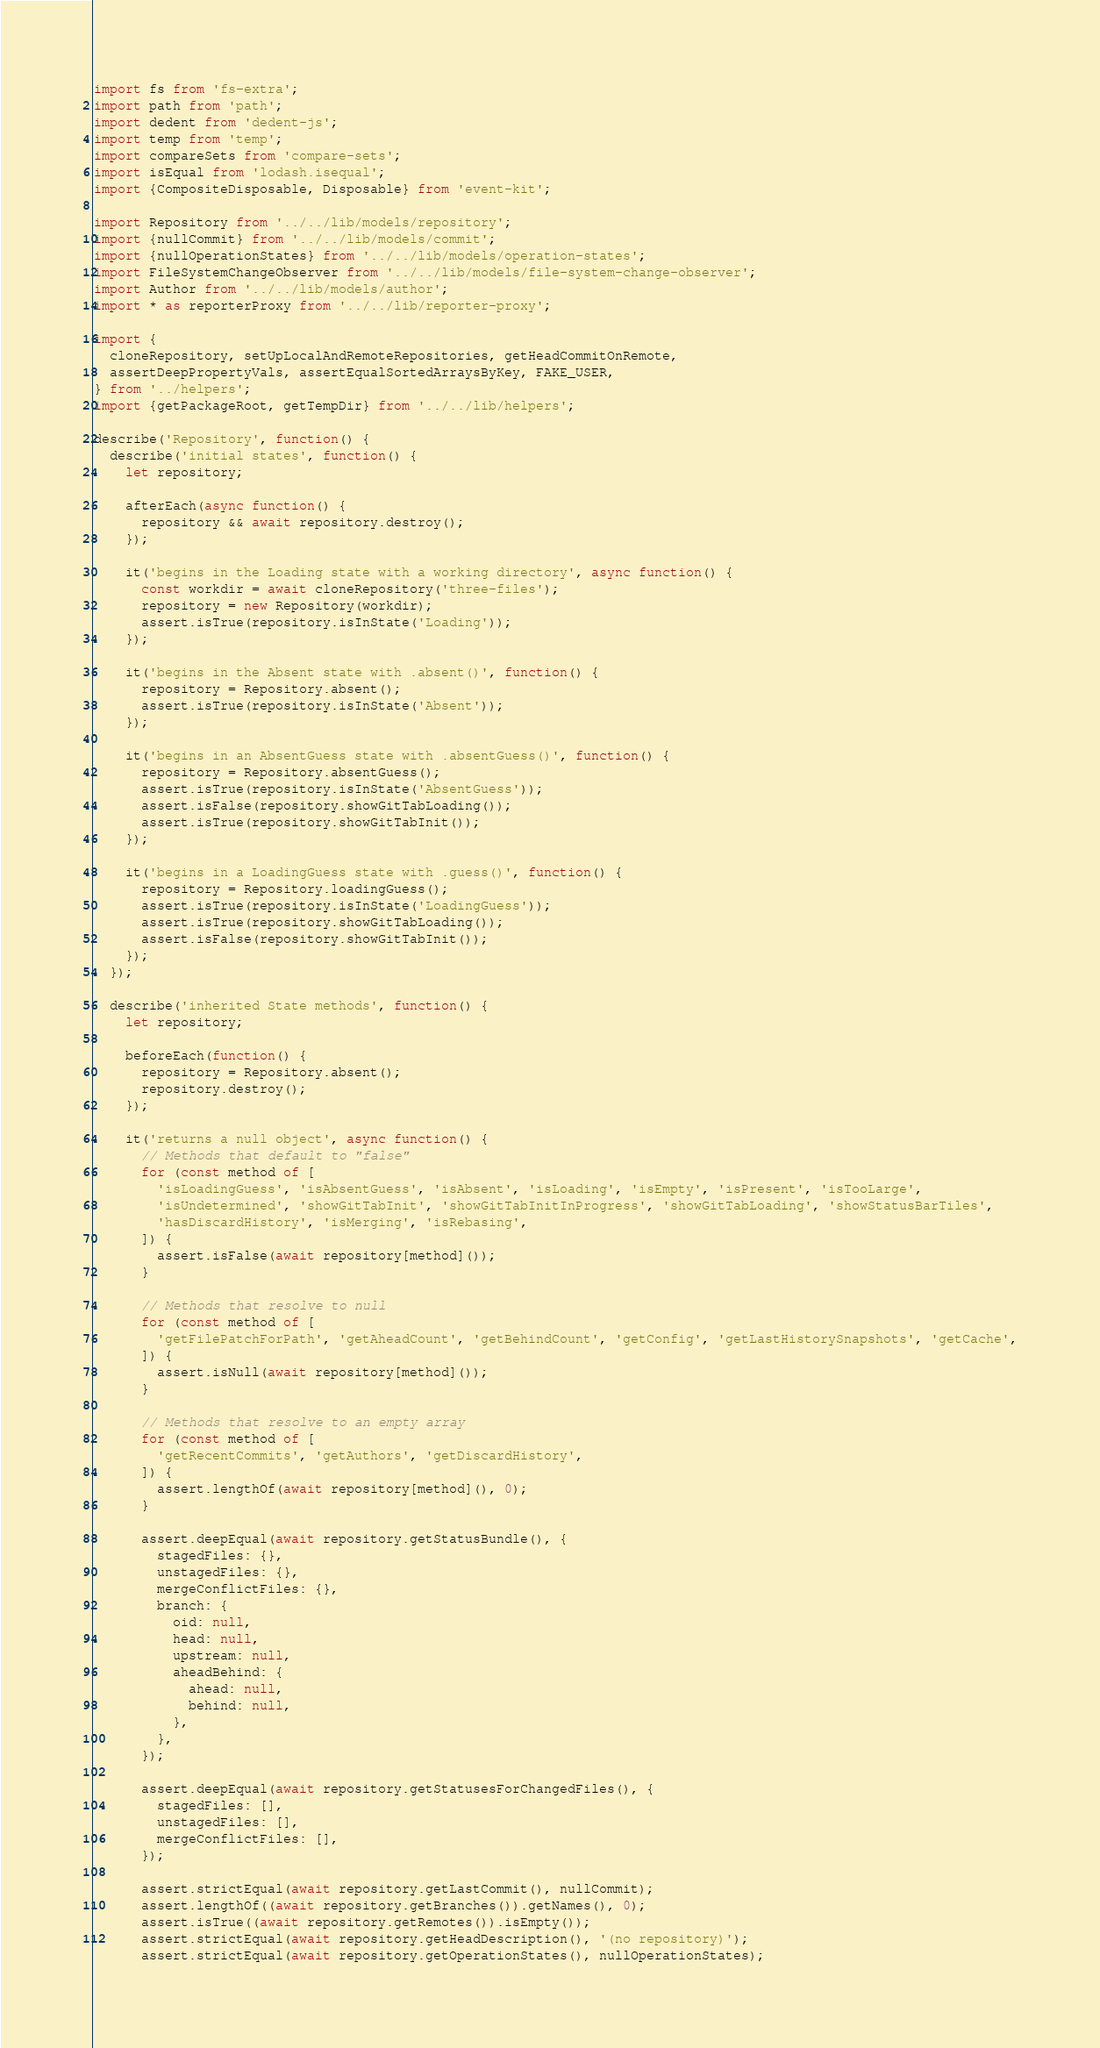<code> <loc_0><loc_0><loc_500><loc_500><_JavaScript_>import fs from 'fs-extra';
import path from 'path';
import dedent from 'dedent-js';
import temp from 'temp';
import compareSets from 'compare-sets';
import isEqual from 'lodash.isequal';
import {CompositeDisposable, Disposable} from 'event-kit';

import Repository from '../../lib/models/repository';
import {nullCommit} from '../../lib/models/commit';
import {nullOperationStates} from '../../lib/models/operation-states';
import FileSystemChangeObserver from '../../lib/models/file-system-change-observer';
import Author from '../../lib/models/author';
import * as reporterProxy from '../../lib/reporter-proxy';

import {
  cloneRepository, setUpLocalAndRemoteRepositories, getHeadCommitOnRemote,
  assertDeepPropertyVals, assertEqualSortedArraysByKey, FAKE_USER,
} from '../helpers';
import {getPackageRoot, getTempDir} from '../../lib/helpers';

describe('Repository', function() {
  describe('initial states', function() {
    let repository;

    afterEach(async function() {
      repository && await repository.destroy();
    });

    it('begins in the Loading state with a working directory', async function() {
      const workdir = await cloneRepository('three-files');
      repository = new Repository(workdir);
      assert.isTrue(repository.isInState('Loading'));
    });

    it('begins in the Absent state with .absent()', function() {
      repository = Repository.absent();
      assert.isTrue(repository.isInState('Absent'));
    });

    it('begins in an AbsentGuess state with .absentGuess()', function() {
      repository = Repository.absentGuess();
      assert.isTrue(repository.isInState('AbsentGuess'));
      assert.isFalse(repository.showGitTabLoading());
      assert.isTrue(repository.showGitTabInit());
    });

    it('begins in a LoadingGuess state with .guess()', function() {
      repository = Repository.loadingGuess();
      assert.isTrue(repository.isInState('LoadingGuess'));
      assert.isTrue(repository.showGitTabLoading());
      assert.isFalse(repository.showGitTabInit());
    });
  });

  describe('inherited State methods', function() {
    let repository;

    beforeEach(function() {
      repository = Repository.absent();
      repository.destroy();
    });

    it('returns a null object', async function() {
      // Methods that default to "false"
      for (const method of [
        'isLoadingGuess', 'isAbsentGuess', 'isAbsent', 'isLoading', 'isEmpty', 'isPresent', 'isTooLarge',
        'isUndetermined', 'showGitTabInit', 'showGitTabInitInProgress', 'showGitTabLoading', 'showStatusBarTiles',
        'hasDiscardHistory', 'isMerging', 'isRebasing',
      ]) {
        assert.isFalse(await repository[method]());
      }

      // Methods that resolve to null
      for (const method of [
        'getFilePatchForPath', 'getAheadCount', 'getBehindCount', 'getConfig', 'getLastHistorySnapshots', 'getCache',
      ]) {
        assert.isNull(await repository[method]());
      }

      // Methods that resolve to an empty array
      for (const method of [
        'getRecentCommits', 'getAuthors', 'getDiscardHistory',
      ]) {
        assert.lengthOf(await repository[method](), 0);
      }

      assert.deepEqual(await repository.getStatusBundle(), {
        stagedFiles: {},
        unstagedFiles: {},
        mergeConflictFiles: {},
        branch: {
          oid: null,
          head: null,
          upstream: null,
          aheadBehind: {
            ahead: null,
            behind: null,
          },
        },
      });

      assert.deepEqual(await repository.getStatusesForChangedFiles(), {
        stagedFiles: [],
        unstagedFiles: [],
        mergeConflictFiles: [],
      });

      assert.strictEqual(await repository.getLastCommit(), nullCommit);
      assert.lengthOf((await repository.getBranches()).getNames(), 0);
      assert.isTrue((await repository.getRemotes()).isEmpty());
      assert.strictEqual(await repository.getHeadDescription(), '(no repository)');
      assert.strictEqual(await repository.getOperationStates(), nullOperationStates);</code> 